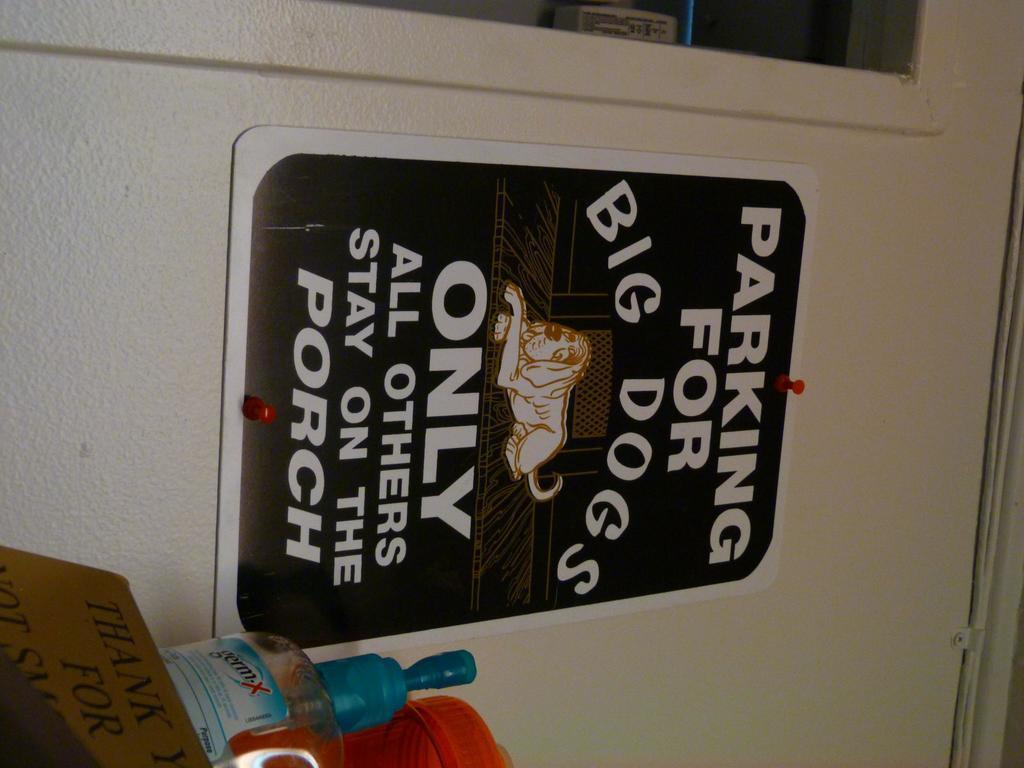Describe this image in one or two sentences. On this white wall there is a poster in black color. Beside this poster there is a card, bottle and jar. 